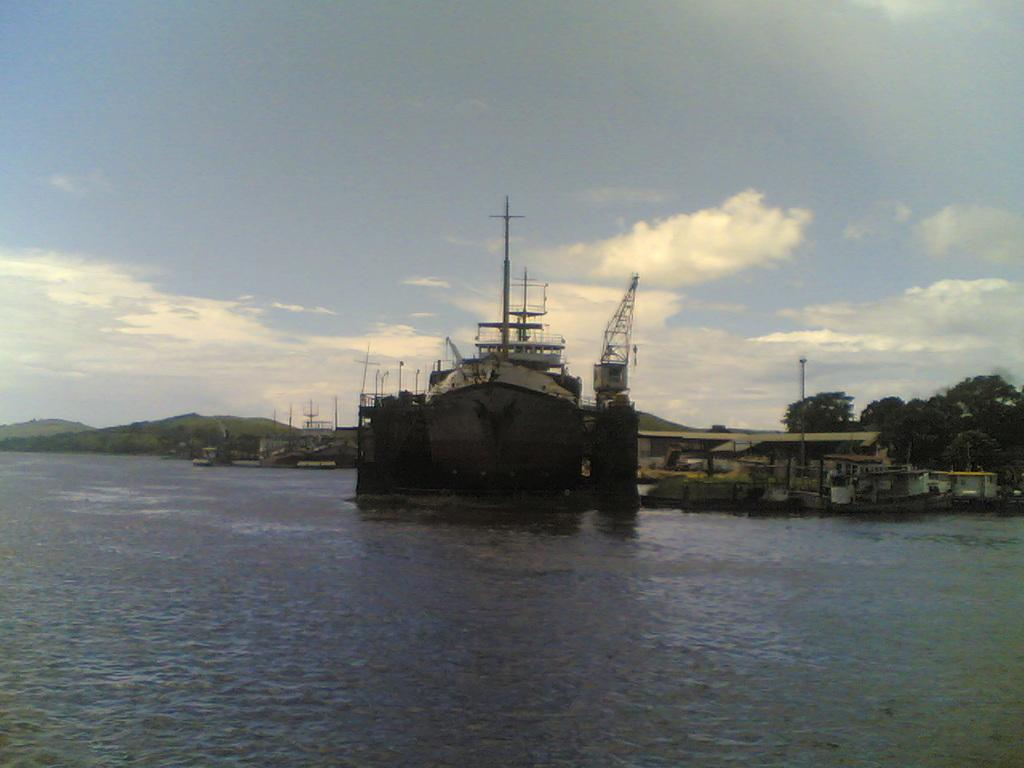What is the main subject in the image? There is a ship in the water in the image. What is the ship floating on? The ship is floating on water in the image. What can be seen in the background of the image? There are trees, clouds in the sky, and poles in the background of the image. What is visible at the top of the image? The sky is visible in the background of the image. Can you tell me how many crooks are on the ship in the image? There is no mention of crooks in the image; the main subject is a ship in the water. What is the nose of the ship like in the image? There is no specific mention of the ship's nose in the image, but it is likely that the ship has a bow or front end. 